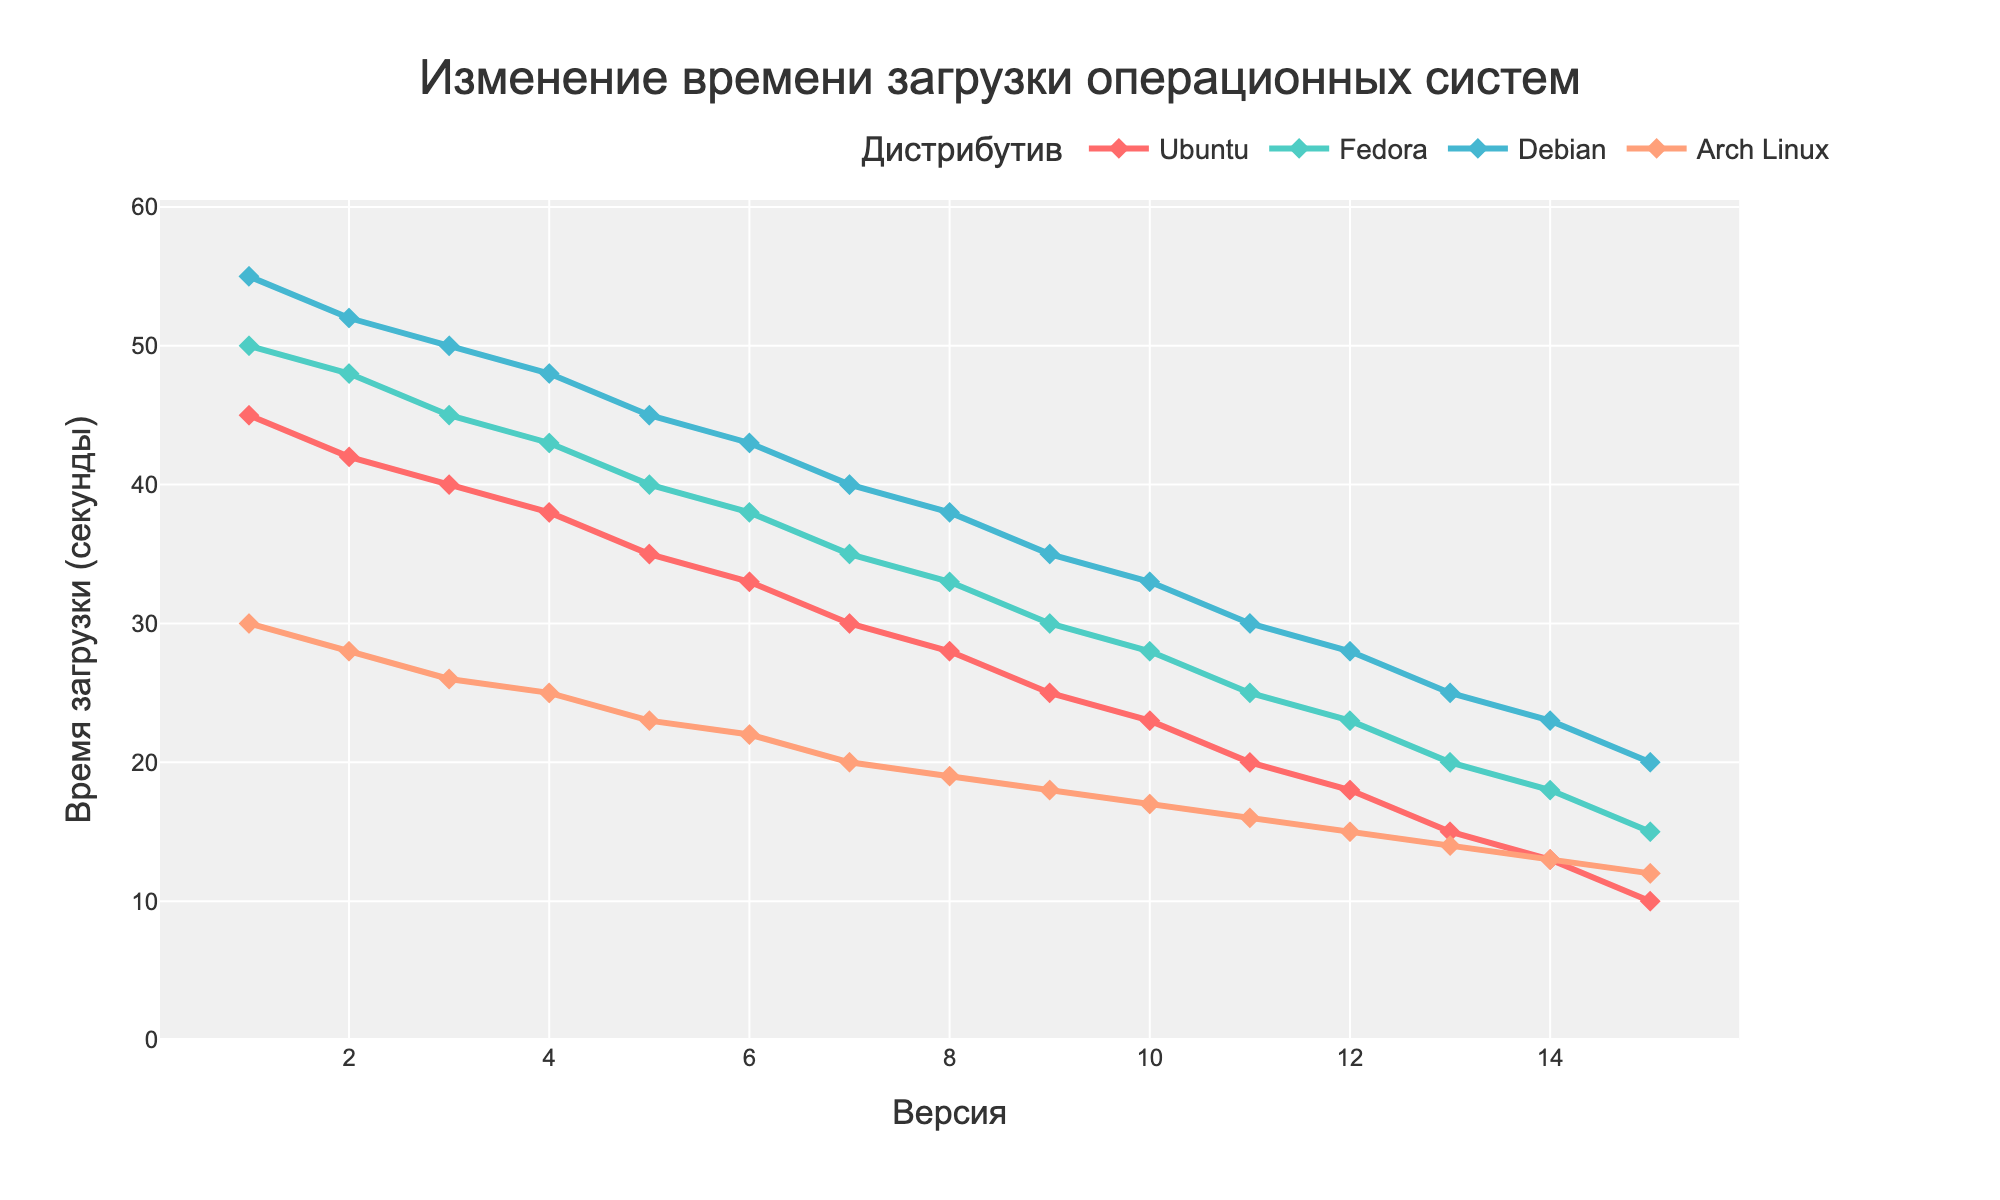What's the trend in boot time for Ubuntu from version 1.0 to 15.0? The trend shows a consistent and gradual decrease in boot time for Ubuntu across versions. Each new version shows a reduction in boot time.
Answer: Gradual decrease Which distribution has the fastest boot time in version 15.0? By examining the boot times at version 15.0, we see that Arch Linux has a boot time of 12 seconds, which is the lowest among all distributions.
Answer: Arch Linux At which version did Debian reach a boot time of 30 seconds? The boot time for Debian reaches 30 seconds at version 11.0, as indicated by tracing the Debian data points.
Answer: Version 11.0 Compare the difference in boot time between Fedora and Arch Linux at version 10.0. Fedora has a boot time of 28 seconds and Arch Linux has a boot time of 17 seconds at version 10.0. The difference in boot time is 28 - 17 = 11 seconds.
Answer: 11 seconds What is the average boot time reduction per version for Ubuntu? Calculating the total reduction from version 1.0 (45 seconds) to version 15.0 (10 seconds), the total reduction is 45 - 10 = 35 seconds. Dividing by the number of versions (14), we get 35 / 14 ≈ 2.5 seconds per version on average.
Answer: 2.5 seconds per version Which distribution shows the slowest rate of improvement in boot time across all versions? By visually comparing the slopes of the lines representing each distribution, Fedora's line appears less steep than others, indicating a slower rate of boot time improvement.
Answer: Fedora By how much did the boot time for Arch Linux improve from version 5.0 to 10.0? Arch Linux boot time at version 5.0 is 23 seconds and at version 10.0 is 17 seconds. The improvement is 23 - 17 = 6 seconds.
Answer: 6 seconds What notable change happens to Debian boot time between versions 10.0 and 11.0? Debian's boot time drops from 33 seconds in version 10.0 to 30 seconds in version 11.0, indicating a significant reduction milestone.
Answer: Significant reduction What is the total boot time reduction for Fedora from version 1.0 to 15.0? Fedora's boot time at version 1.0 is 50 seconds, and it decreases to 15 seconds by version 15.0. The total reduction is 50 - 15 = 35 seconds.
Answer: 35 seconds Which two distributions show a similar trend in boot time reduction and how do their rates compare? Both Ubuntu and Debian exhibit consistent decreases in boot times. However, Ubuntu shows a slightly steeper decline, indicating a faster rate of improvement compared to Debian.
Answer: Ubuntu and Debian, with Ubuntu having a faster rate 